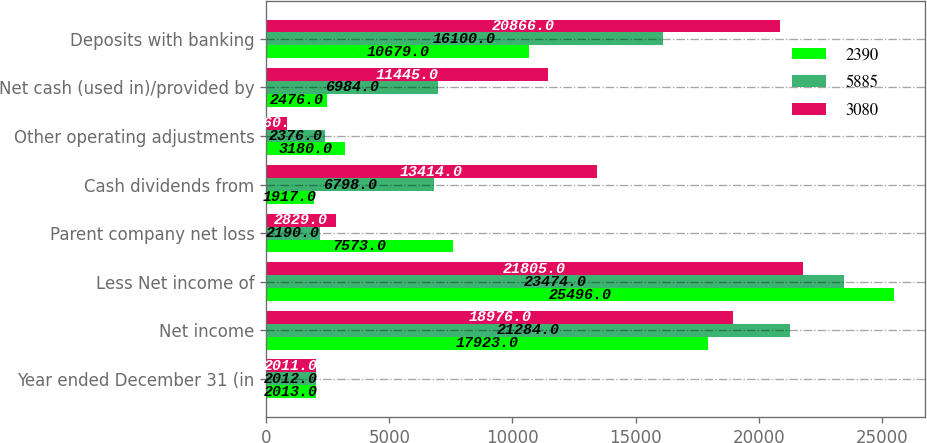Convert chart. <chart><loc_0><loc_0><loc_500><loc_500><stacked_bar_chart><ecel><fcel>Year ended December 31 (in<fcel>Net income<fcel>Less Net income of<fcel>Parent company net loss<fcel>Cash dividends from<fcel>Other operating adjustments<fcel>Net cash (used in)/provided by<fcel>Deposits with banking<nl><fcel>2390<fcel>2013<fcel>17923<fcel>25496<fcel>7573<fcel>1917<fcel>3180<fcel>2476<fcel>10679<nl><fcel>5885<fcel>2012<fcel>21284<fcel>23474<fcel>2190<fcel>6798<fcel>2376<fcel>6984<fcel>16100<nl><fcel>3080<fcel>2011<fcel>18976<fcel>21805<fcel>2829<fcel>13414<fcel>860<fcel>11445<fcel>20866<nl></chart> 